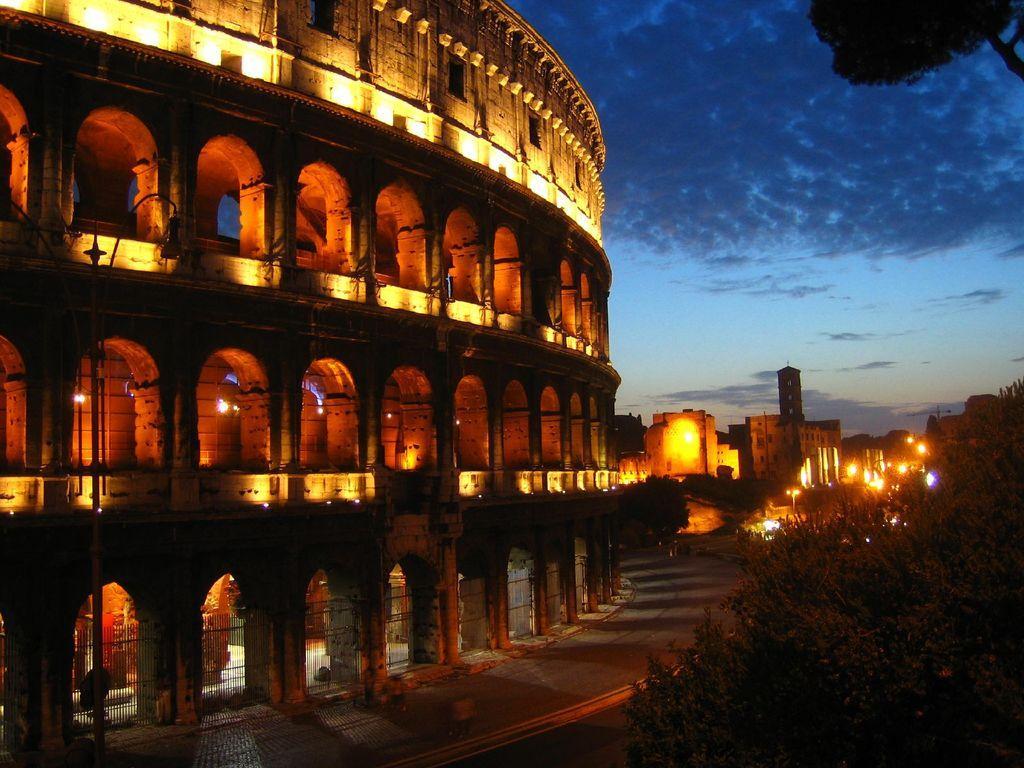Could you give a brief overview of what you see in this image? In the picture I can see buildings, trees, street lights, fence and some other objects. In the background I can see the sky. 